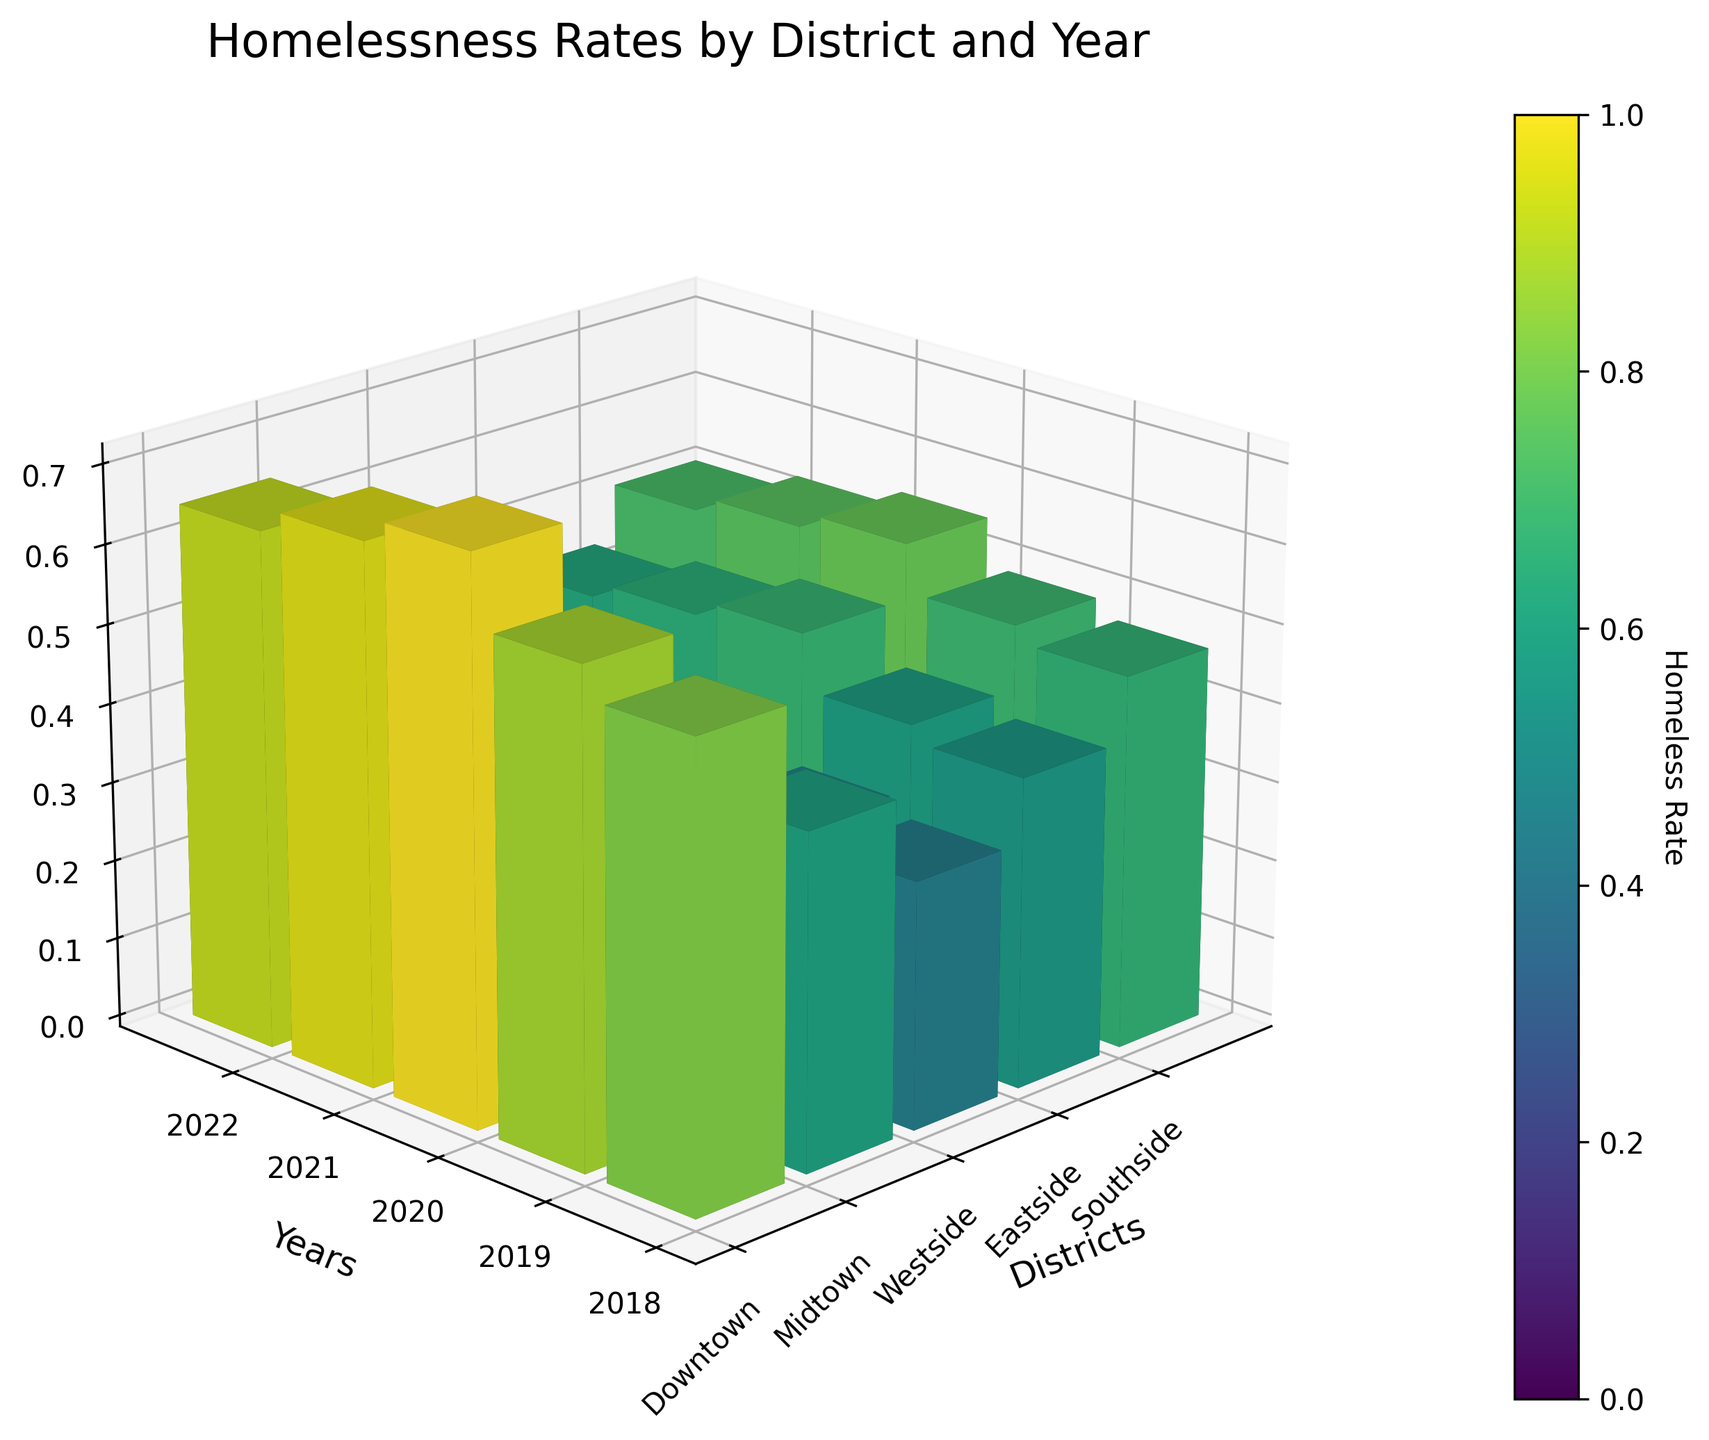What years are displayed on the Y-axis? The Y-axis represents the years displayed in the figure. By observing the Y-axis ticks, we can see it includes '2018', '2019', '2020', '2021', and '2022'.
Answer: 2018, 2019, 2020, 2021, 2022 What is the title of the figure? The title is displayed at the top of the figure. It states "Homelessness Rates by District and Year".
Answer: Homelessness Rates by District and Year Which district had the highest homelessness rate in 2020? To find this, locate the year 2020 on the Y-axis, then observe the heights of the bars for each district. The highest bar among them represents the district with the highest homelessness rate. The Downtown district bar is the highest.
Answer: Downtown What was the difference in homelessness rates between Midtown and Southside in 2021? Find the bars for Midtown and Southside for the year 2021. Note their heights, which represent their respective homelessness rates. Midtown's rate looks approximately 0.51, and Southside's is about 0.53. The difference is 0.53 - 0.51 = 0.02.
Answer: 0.02 Which year had the lowest homelessness rate for the Westside district? Identify the Westside bars across all years and note their heights. The lowest bar corresponds to the year with the lowest homelessness rate. The bar for 2022 is the lowest.
Answer: 2022 How does the homelessness rate change over the years for the Downtown district? Track the height of the bars for Downtown from 2018 to 2022. The heights represent the homelessness rates: 0.58, 0.62, 0.71, 0.68, and 0.65. The rates first increase to 0.71 in 2020 and then decrease.
Answer: Increases, then decreases What are the colors used in the bar chart? The figure uses a color gradient (color map) to represent different homelessness rates, where the colors range from lighter (lower value) to darker (higher value) shades.
Answer: Gradient of light to dark Which year had the highest average homelessness rate across all districts? Calculate the average rate for each year by summing the heights of the bars for all districts in that year and dividing by the number of districts. Compare the averages, and the year with the highest value is 2020.
Answer: 2020 What is the major contributing factor to homelessness in the Eastside district in 2019 and 2022? Referring to the provided data, the major contributing factor to homelessness in the Eastside district for both years is Substance Abuse.
Answer: Substance Abuse 